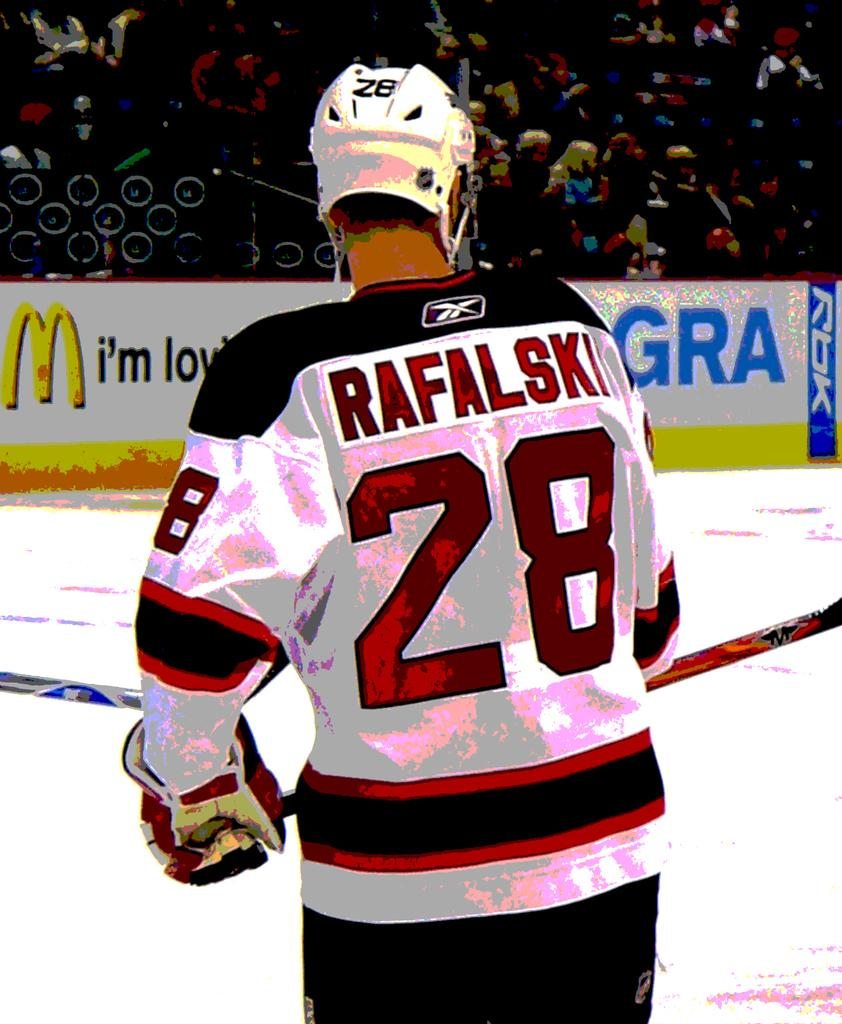What can be seen in the image? There is a person in the image. What is the person wearing on their head? The person is wearing a helmet. What type of clothing is the person wearing? The person is wearing a colorful dress. What can be seen beneath the person's feet? The ground is visible in the image. What is happening in the background of the image? There is a crowd of people in the background of the image. Has the image been altered in any way? Yes, the image has been edited. What type of cow can be seen in the image? There is no cow present in the image. How does the person care for the insect in the image? There is no insect present in the image, and therefore no interaction with an insect can be observed. 